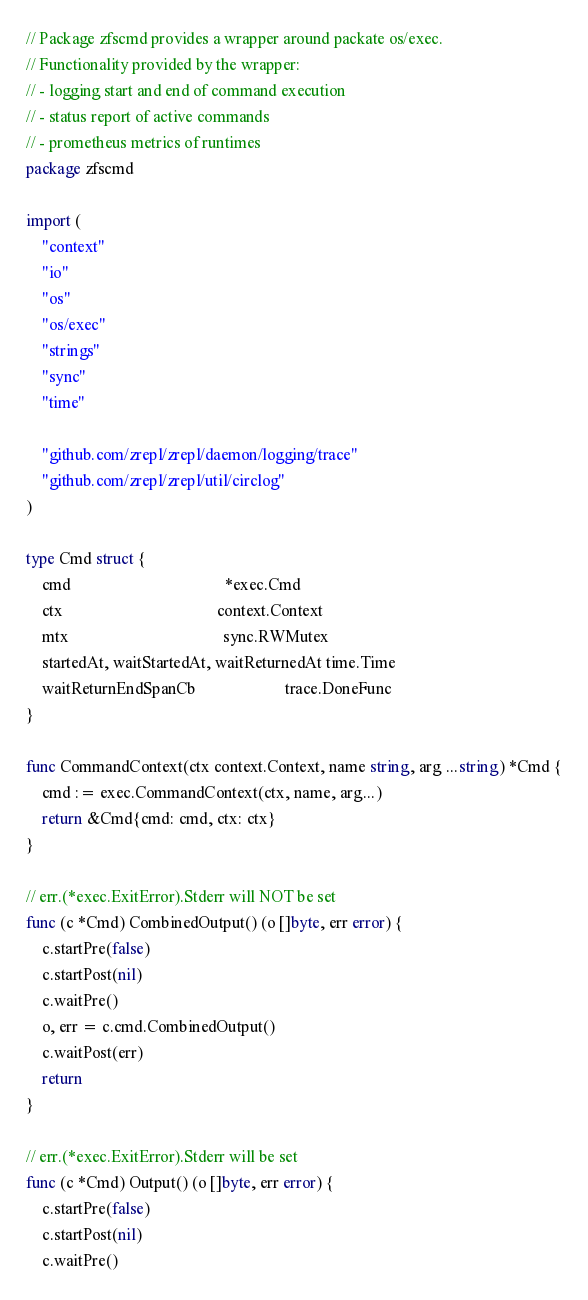<code> <loc_0><loc_0><loc_500><loc_500><_Go_>// Package zfscmd provides a wrapper around packate os/exec.
// Functionality provided by the wrapper:
// - logging start and end of command execution
// - status report of active commands
// - prometheus metrics of runtimes
package zfscmd

import (
	"context"
	"io"
	"os"
	"os/exec"
	"strings"
	"sync"
	"time"

	"github.com/zrepl/zrepl/daemon/logging/trace"
	"github.com/zrepl/zrepl/util/circlog"
)

type Cmd struct {
	cmd                                      *exec.Cmd
	ctx                                      context.Context
	mtx                                      sync.RWMutex
	startedAt, waitStartedAt, waitReturnedAt time.Time
	waitReturnEndSpanCb                      trace.DoneFunc
}

func CommandContext(ctx context.Context, name string, arg ...string) *Cmd {
	cmd := exec.CommandContext(ctx, name, arg...)
	return &Cmd{cmd: cmd, ctx: ctx}
}

// err.(*exec.ExitError).Stderr will NOT be set
func (c *Cmd) CombinedOutput() (o []byte, err error) {
	c.startPre(false)
	c.startPost(nil)
	c.waitPre()
	o, err = c.cmd.CombinedOutput()
	c.waitPost(err)
	return
}

// err.(*exec.ExitError).Stderr will be set
func (c *Cmd) Output() (o []byte, err error) {
	c.startPre(false)
	c.startPost(nil)
	c.waitPre()</code> 